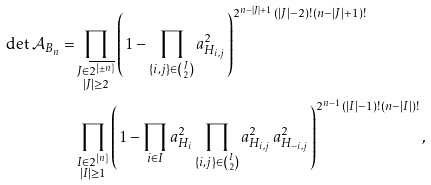<formula> <loc_0><loc_0><loc_500><loc_500>\det \mathcal { A } _ { B _ { n } } = & \prod _ { \substack { J \in \overline { 2 ^ { [ \pm n ] } } \\ | J | \geq 2 } } \left ( 1 - \prod _ { \{ i , j \} \in \binom { J } { 2 } } a _ { H _ { i , j } } ^ { 2 } \right ) ^ { 2 ^ { n - | J | + 1 } \, ( | J | - 2 ) ! \, ( n - | J | + 1 ) ! } \\ & \prod _ { \substack { I \in 2 ^ { [ n ] } \\ | I | \geq 1 } } \left ( 1 - \prod _ { i \in I } a _ { H _ { i } } ^ { 2 } \prod _ { \{ i , j \} \in \binom { I } { 2 } } a _ { H _ { i , j } } ^ { 2 } \, a _ { H _ { - i , j } } ^ { 2 } \right ) ^ { 2 ^ { n - 1 } \, ( | I | - 1 ) ! \, ( n - | I | ) ! } ,</formula> 